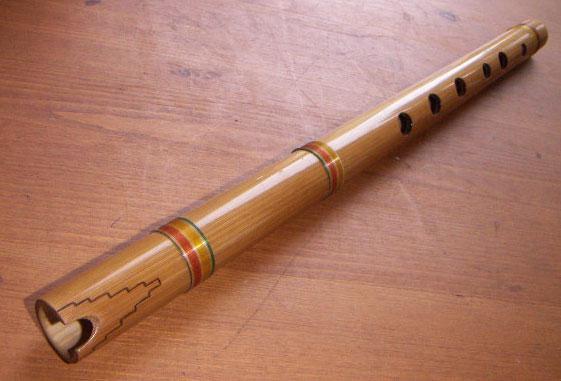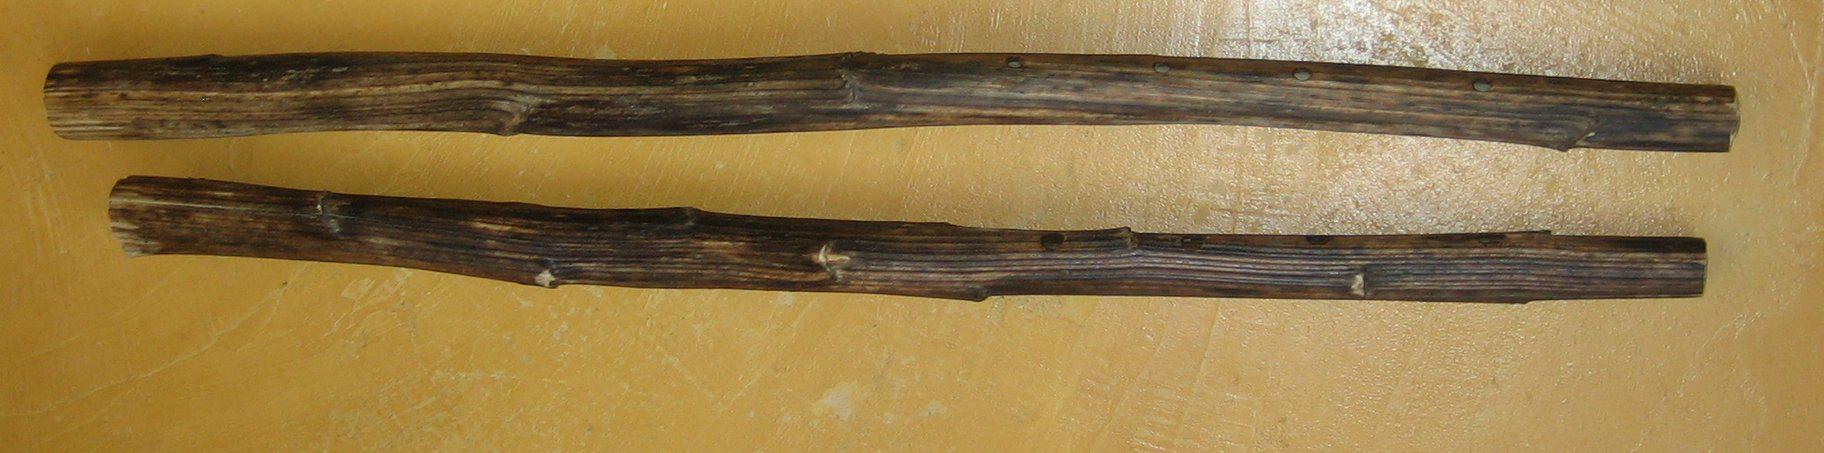The first image is the image on the left, the second image is the image on the right. Analyze the images presented: Is the assertion "there are two flutes in the image pair" valid? Answer yes or no. No. The first image is the image on the left, the second image is the image on the right. For the images displayed, is the sentence "Each image contains one perforated, stick-like instrument displayed at an angle, and the right image shows an instrument with a leather tie on one end." factually correct? Answer yes or no. No. 